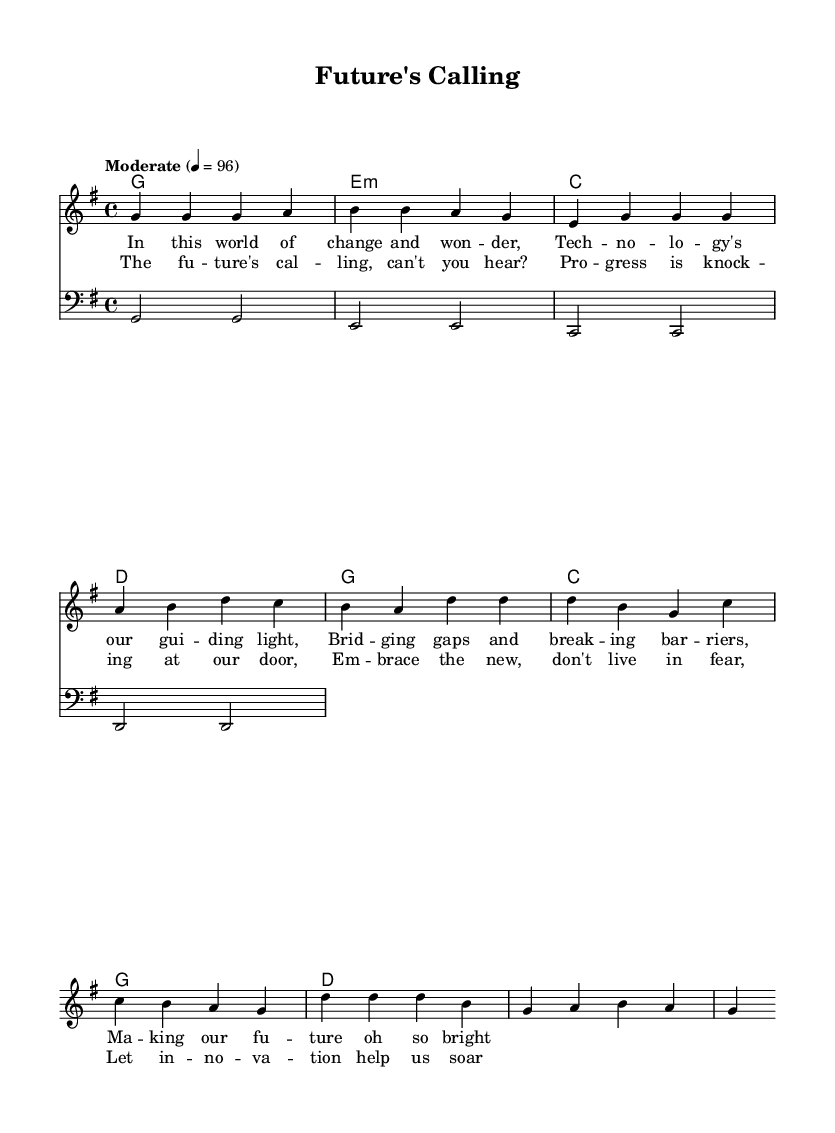What is the key signature of this music? The key signature is G major, which has one sharp (F#). This can be determined from the 'key g \major' statement in the global block.
Answer: G major What is the time signature of the piece? The time signature is 4/4, indicated by the ' \time 4/4 ' in the global block. This means there are four beats in each measure.
Answer: 4/4 What is the tempo marking given in the music? The tempo marking is "Moderate" 4 = 96, which means to play at a moderate speed, specifically 96 beats per minute. This is specified in the global block.
Answer: Moderate 4 = 96 How many measures are in the verse? There are four measures in the verse section, as can be seen by counting the distinct groups of notes and bars in the melody section of the code.
Answer: Four What is the primary chord used in the chorus? The primary chord used in the chorus is G major, as it appears most frequently in the chorus section indicated by the 'harmonies' in the chordmode.
Answer: G What lyrical theme is portrayed in the chorus? The theme of the chorus is about embracing progress and innovation, as highlighted by phrases like "The future's calling" and "Embrace the new." This is evident in the lyric content provided in the chorus section.
Answer: Progress and innovation How does the structure of this song reflect soul music characteristics? The structure features repetitive lyrical phrases and a strong emotive message, which are key characteristics of soul music, allowing the themes of progress and innovation to be highlighted through a call-and-response style.
Answer: Call-and-response 